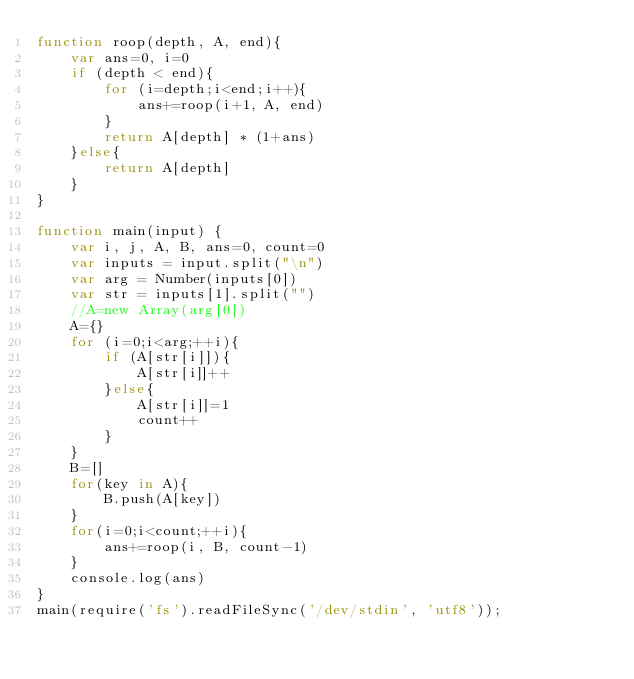<code> <loc_0><loc_0><loc_500><loc_500><_JavaScript_>function roop(depth, A, end){
    var ans=0, i=0
    if (depth < end){
        for (i=depth;i<end;i++){
            ans+=roop(i+1, A, end)
        }
        return A[depth] * (1+ans)
    }else{
        return A[depth]
    }
}

function main(input) {
    var i, j, A, B, ans=0, count=0
    var inputs = input.split("\n")
    var arg = Number(inputs[0])
    var str = inputs[1].split("")
    //A=new Array(arg[0])
    A={}
    for (i=0;i<arg;++i){
        if (A[str[i]]){
            A[str[i]]++
        }else{
            A[str[i]]=1
            count++
        }
    }
    B=[]
    for(key in A){
        B.push(A[key])
    }
    for(i=0;i<count;++i){
        ans+=roop(i, B, count-1)
    }
    console.log(ans)
}
main(require('fs').readFileSync('/dev/stdin', 'utf8'));</code> 